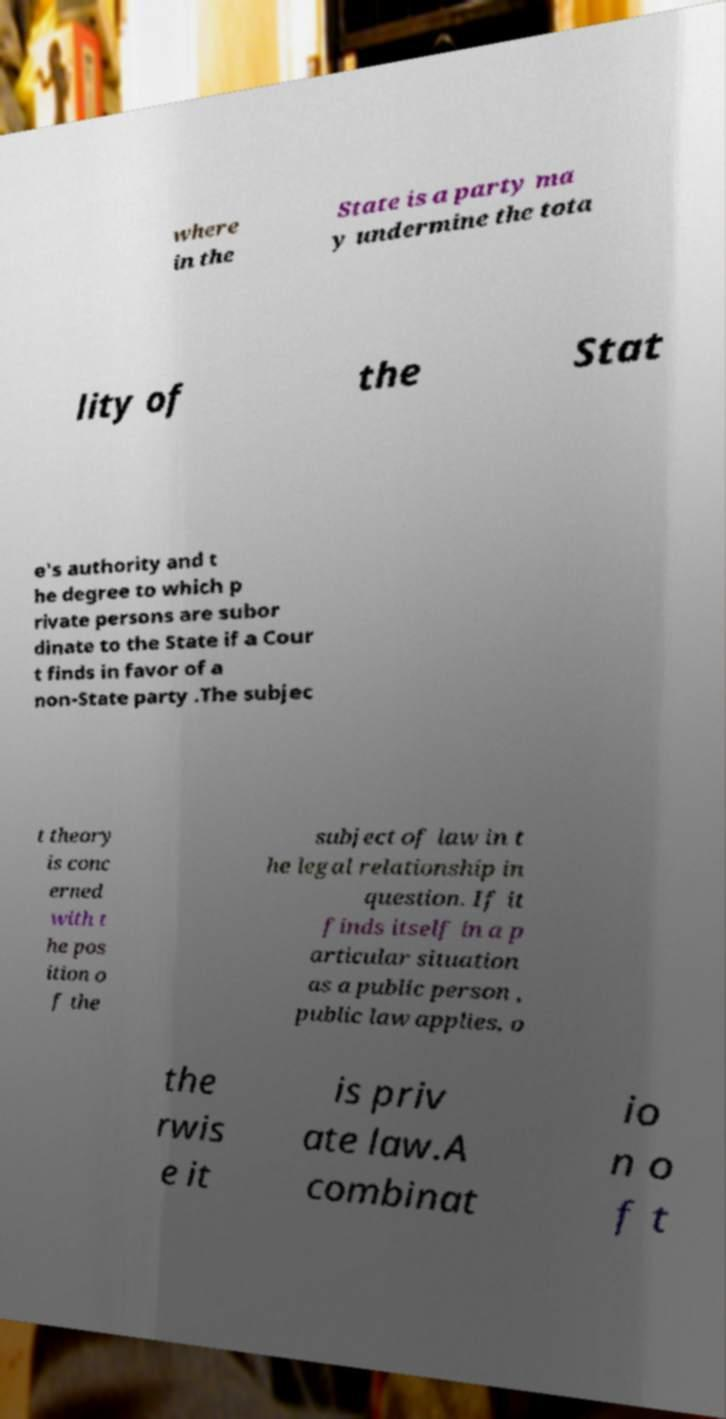What messages or text are displayed in this image? I need them in a readable, typed format. where in the State is a party ma y undermine the tota lity of the Stat e's authority and t he degree to which p rivate persons are subor dinate to the State if a Cour t finds in favor of a non-State party .The subjec t theory is conc erned with t he pos ition o f the subject of law in t he legal relationship in question. If it finds itself in a p articular situation as a public person , public law applies, o the rwis e it is priv ate law.A combinat io n o f t 